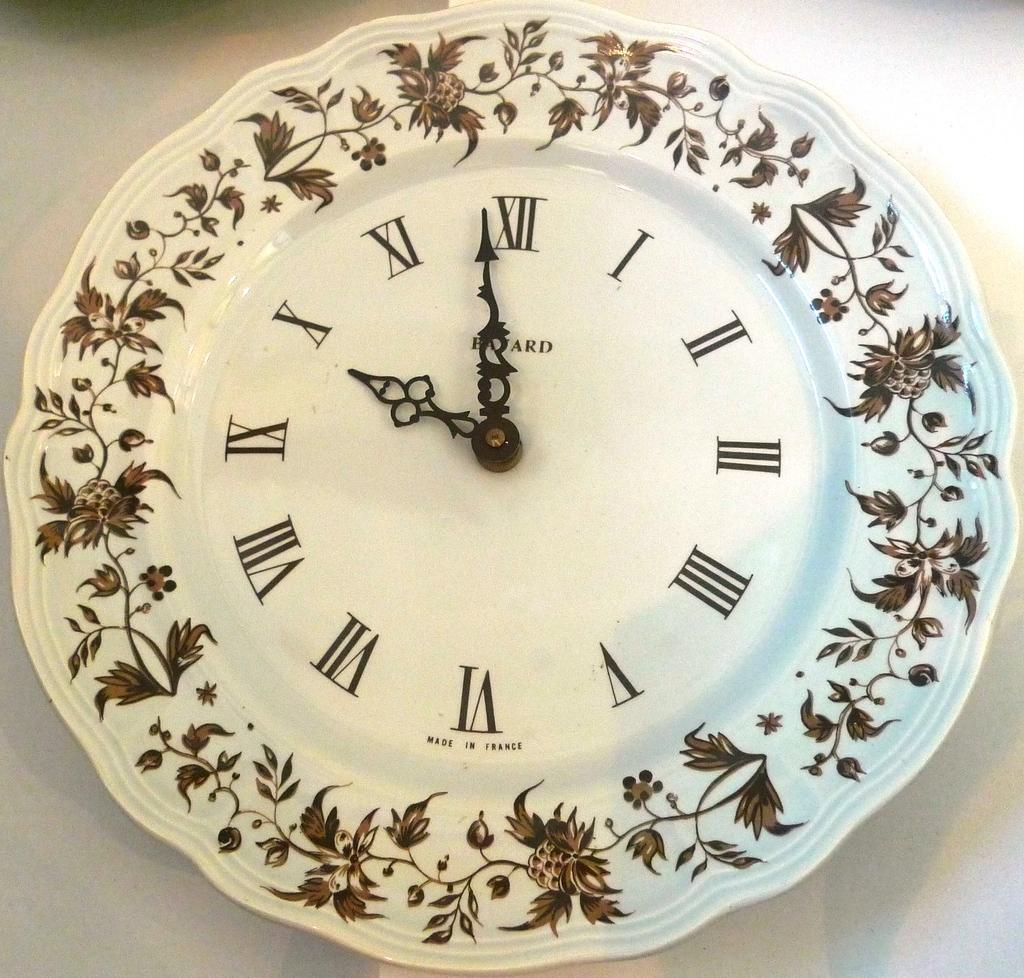<image>
Offer a succinct explanation of the picture presented. A white clock with flowers around the edges reads almost 10:00. 